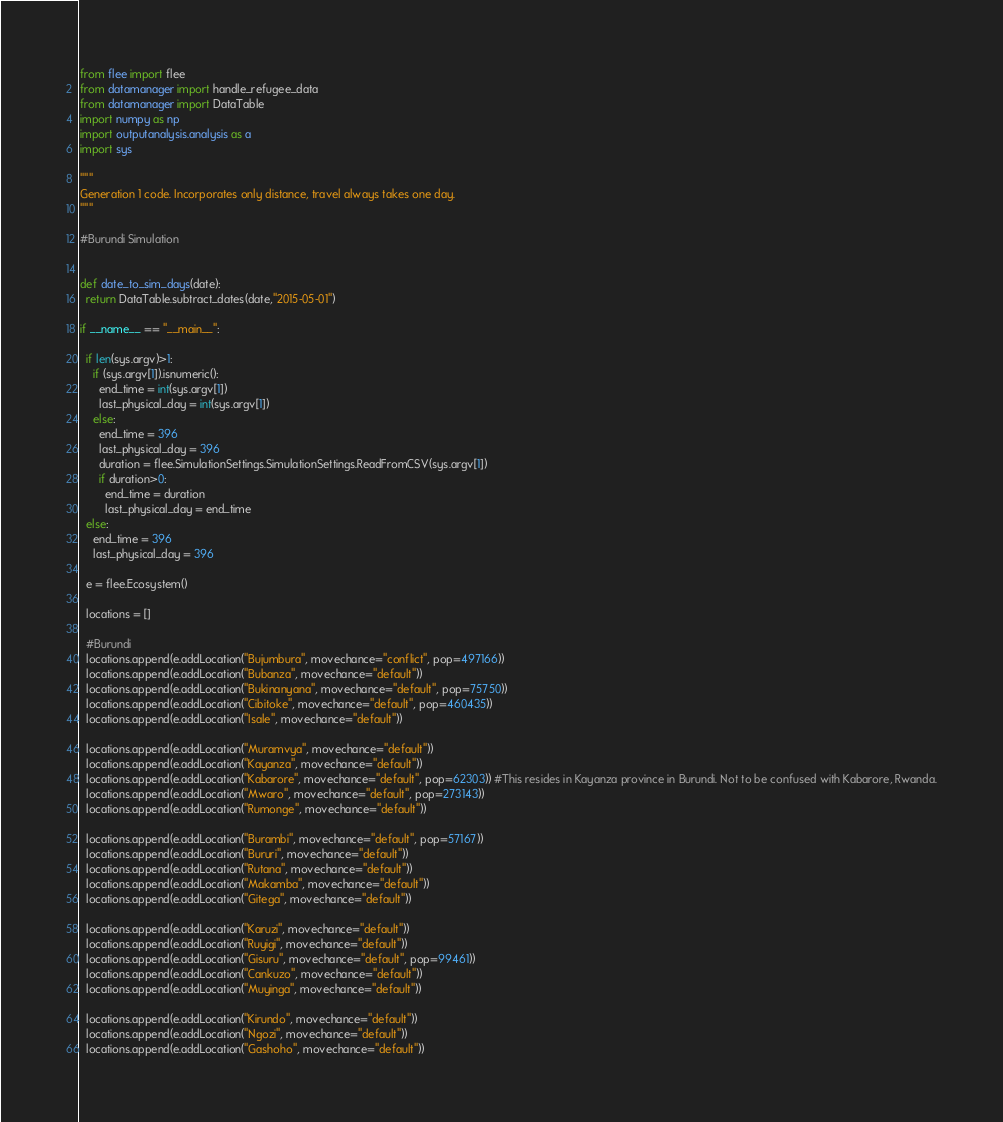Convert code to text. <code><loc_0><loc_0><loc_500><loc_500><_Python_>from flee import flee
from datamanager import handle_refugee_data
from datamanager import DataTable
import numpy as np
import outputanalysis.analysis as a
import sys

"""
Generation 1 code. Incorporates only distance, travel always takes one day.
"""

#Burundi Simulation


def date_to_sim_days(date):
  return DataTable.subtract_dates(date,"2015-05-01")

if __name__ == "__main__":

  if len(sys.argv)>1:
    if (sys.argv[1]).isnumeric():
      end_time = int(sys.argv[1])
      last_physical_day = int(sys.argv[1])
    else:
      end_time = 396
      last_physical_day = 396
      duration = flee.SimulationSettings.SimulationSettings.ReadFromCSV(sys.argv[1])
      if duration>0:
        end_time = duration
        last_physical_day = end_time
  else:
    end_time = 396
    last_physical_day = 396

  e = flee.Ecosystem()

  locations = []

  #Burundi
  locations.append(e.addLocation("Bujumbura", movechance="conflict", pop=497166))
  locations.append(e.addLocation("Bubanza", movechance="default"))
  locations.append(e.addLocation("Bukinanyana", movechance="default", pop=75750))
  locations.append(e.addLocation("Cibitoke", movechance="default", pop=460435))
  locations.append(e.addLocation("Isale", movechance="default"))

  locations.append(e.addLocation("Muramvya", movechance="default"))
  locations.append(e.addLocation("Kayanza", movechance="default"))
  locations.append(e.addLocation("Kabarore", movechance="default", pop=62303)) #This resides in Kayanza province in Burundi. Not to be confused with Kabarore, Rwanda.
  locations.append(e.addLocation("Mwaro", movechance="default", pop=273143))
  locations.append(e.addLocation("Rumonge", movechance="default"))

  locations.append(e.addLocation("Burambi", movechance="default", pop=57167))
  locations.append(e.addLocation("Bururi", movechance="default"))
  locations.append(e.addLocation("Rutana", movechance="default"))
  locations.append(e.addLocation("Makamba", movechance="default"))
  locations.append(e.addLocation("Gitega", movechance="default"))

  locations.append(e.addLocation("Karuzi", movechance="default"))
  locations.append(e.addLocation("Ruyigi", movechance="default"))
  locations.append(e.addLocation("Gisuru", movechance="default", pop=99461))
  locations.append(e.addLocation("Cankuzo", movechance="default"))
  locations.append(e.addLocation("Muyinga", movechance="default"))

  locations.append(e.addLocation("Kirundo", movechance="default"))
  locations.append(e.addLocation("Ngozi", movechance="default"))
  locations.append(e.addLocation("Gashoho", movechance="default"))</code> 